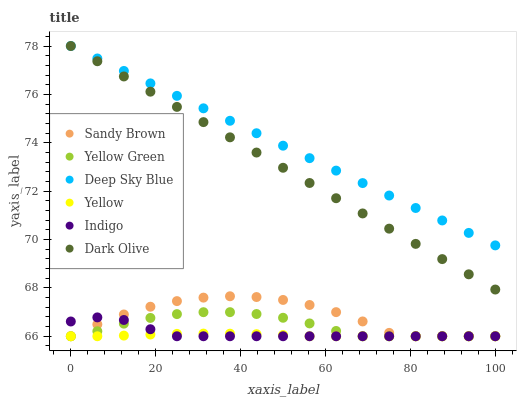Does Yellow have the minimum area under the curve?
Answer yes or no. Yes. Does Deep Sky Blue have the maximum area under the curve?
Answer yes or no. Yes. Does Yellow Green have the minimum area under the curve?
Answer yes or no. No. Does Yellow Green have the maximum area under the curve?
Answer yes or no. No. Is Dark Olive the smoothest?
Answer yes or no. Yes. Is Sandy Brown the roughest?
Answer yes or no. Yes. Is Yellow Green the smoothest?
Answer yes or no. No. Is Yellow Green the roughest?
Answer yes or no. No. Does Indigo have the lowest value?
Answer yes or no. Yes. Does Dark Olive have the lowest value?
Answer yes or no. No. Does Deep Sky Blue have the highest value?
Answer yes or no. Yes. Does Yellow Green have the highest value?
Answer yes or no. No. Is Sandy Brown less than Deep Sky Blue?
Answer yes or no. Yes. Is Deep Sky Blue greater than Yellow Green?
Answer yes or no. Yes. Does Yellow Green intersect Yellow?
Answer yes or no. Yes. Is Yellow Green less than Yellow?
Answer yes or no. No. Is Yellow Green greater than Yellow?
Answer yes or no. No. Does Sandy Brown intersect Deep Sky Blue?
Answer yes or no. No. 